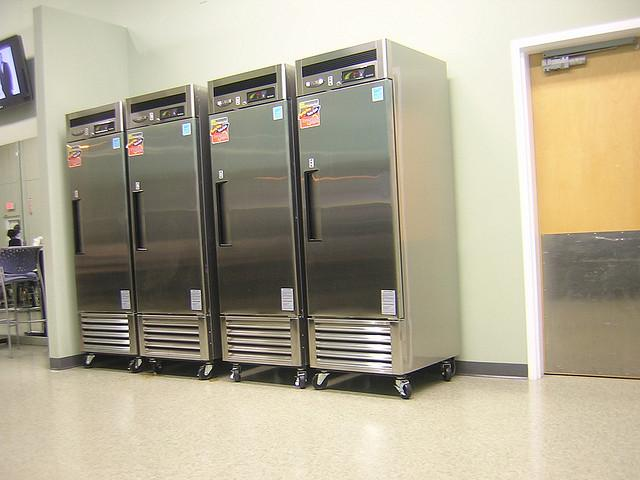What temperature do these devices keep things? cold 